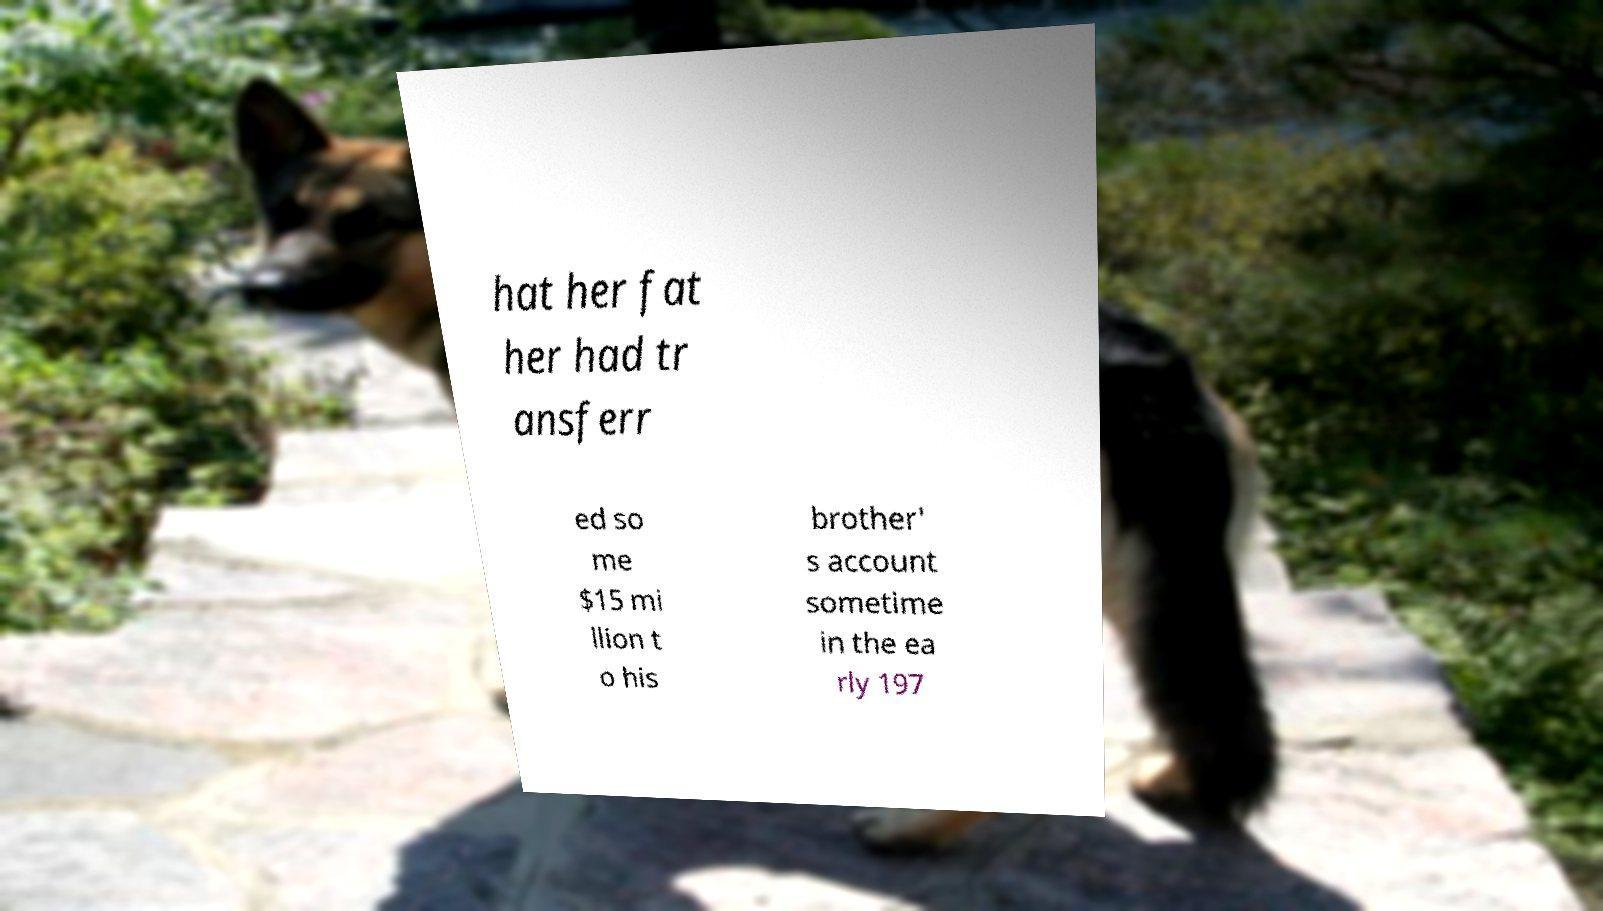Please read and relay the text visible in this image. What does it say? hat her fat her had tr ansferr ed so me $15 mi llion t o his brother' s account sometime in the ea rly 197 